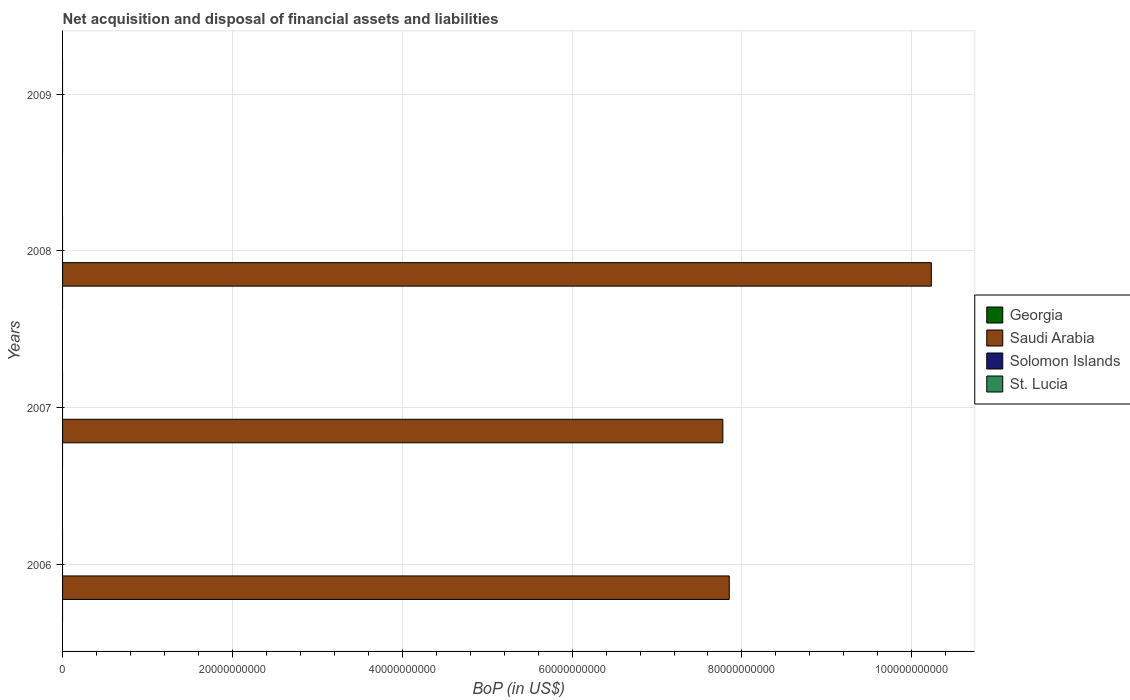How many different coloured bars are there?
Your answer should be compact. 1. Are the number of bars on each tick of the Y-axis equal?
Your answer should be compact. No. How many bars are there on the 4th tick from the bottom?
Give a very brief answer. 0. What is the label of the 4th group of bars from the top?
Provide a short and direct response. 2006. In how many cases, is the number of bars for a given year not equal to the number of legend labels?
Make the answer very short. 4. Across all years, what is the maximum Balance of Payments in Saudi Arabia?
Provide a short and direct response. 1.02e+11. What is the difference between the Balance of Payments in Saudi Arabia in 2006 and that in 2008?
Provide a short and direct response. -2.38e+1. What is the average Balance of Payments in Saudi Arabia per year?
Offer a terse response. 6.46e+1. What is the difference between the highest and the second highest Balance of Payments in Saudi Arabia?
Your answer should be compact. 2.38e+1. What is the difference between the highest and the lowest Balance of Payments in Saudi Arabia?
Keep it short and to the point. 1.02e+11. In how many years, is the Balance of Payments in Solomon Islands greater than the average Balance of Payments in Solomon Islands taken over all years?
Your response must be concise. 0. Is the sum of the Balance of Payments in Saudi Arabia in 2006 and 2007 greater than the maximum Balance of Payments in Solomon Islands across all years?
Make the answer very short. Yes. Is it the case that in every year, the sum of the Balance of Payments in Solomon Islands and Balance of Payments in Saudi Arabia is greater than the sum of Balance of Payments in Georgia and Balance of Payments in St. Lucia?
Offer a very short reply. No. Is it the case that in every year, the sum of the Balance of Payments in Saudi Arabia and Balance of Payments in Georgia is greater than the Balance of Payments in St. Lucia?
Ensure brevity in your answer.  No. Are all the bars in the graph horizontal?
Provide a succinct answer. Yes. How many years are there in the graph?
Provide a succinct answer. 4. What is the difference between two consecutive major ticks on the X-axis?
Give a very brief answer. 2.00e+1. Are the values on the major ticks of X-axis written in scientific E-notation?
Provide a short and direct response. No. Does the graph contain any zero values?
Your response must be concise. Yes. Does the graph contain grids?
Your response must be concise. Yes. How are the legend labels stacked?
Give a very brief answer. Vertical. What is the title of the graph?
Your response must be concise. Net acquisition and disposal of financial assets and liabilities. Does "Samoa" appear as one of the legend labels in the graph?
Make the answer very short. No. What is the label or title of the X-axis?
Provide a short and direct response. BoP (in US$). What is the label or title of the Y-axis?
Offer a very short reply. Years. What is the BoP (in US$) in Georgia in 2006?
Keep it short and to the point. 0. What is the BoP (in US$) of Saudi Arabia in 2006?
Your answer should be very brief. 7.85e+1. What is the BoP (in US$) in Solomon Islands in 2006?
Provide a short and direct response. 0. What is the BoP (in US$) in Saudi Arabia in 2007?
Provide a succinct answer. 7.78e+1. What is the BoP (in US$) in Solomon Islands in 2007?
Ensure brevity in your answer.  0. What is the BoP (in US$) in St. Lucia in 2007?
Give a very brief answer. 0. What is the BoP (in US$) of Saudi Arabia in 2008?
Offer a very short reply. 1.02e+11. What is the BoP (in US$) of Solomon Islands in 2008?
Provide a short and direct response. 0. What is the BoP (in US$) in Georgia in 2009?
Offer a terse response. 0. What is the BoP (in US$) of Saudi Arabia in 2009?
Offer a very short reply. 0. What is the BoP (in US$) in Solomon Islands in 2009?
Provide a short and direct response. 0. Across all years, what is the maximum BoP (in US$) of Saudi Arabia?
Provide a succinct answer. 1.02e+11. Across all years, what is the minimum BoP (in US$) of Saudi Arabia?
Offer a very short reply. 0. What is the total BoP (in US$) in Georgia in the graph?
Provide a succinct answer. 0. What is the total BoP (in US$) in Saudi Arabia in the graph?
Your answer should be compact. 2.59e+11. What is the total BoP (in US$) of Solomon Islands in the graph?
Your response must be concise. 0. What is the difference between the BoP (in US$) of Saudi Arabia in 2006 and that in 2007?
Ensure brevity in your answer.  7.55e+08. What is the difference between the BoP (in US$) in Saudi Arabia in 2006 and that in 2008?
Provide a short and direct response. -2.38e+1. What is the difference between the BoP (in US$) of Saudi Arabia in 2007 and that in 2008?
Your answer should be very brief. -2.45e+1. What is the average BoP (in US$) of Georgia per year?
Your answer should be very brief. 0. What is the average BoP (in US$) of Saudi Arabia per year?
Give a very brief answer. 6.46e+1. What is the average BoP (in US$) of St. Lucia per year?
Keep it short and to the point. 0. What is the ratio of the BoP (in US$) in Saudi Arabia in 2006 to that in 2007?
Ensure brevity in your answer.  1.01. What is the ratio of the BoP (in US$) of Saudi Arabia in 2006 to that in 2008?
Your response must be concise. 0.77. What is the ratio of the BoP (in US$) of Saudi Arabia in 2007 to that in 2008?
Ensure brevity in your answer.  0.76. What is the difference between the highest and the second highest BoP (in US$) of Saudi Arabia?
Make the answer very short. 2.38e+1. What is the difference between the highest and the lowest BoP (in US$) in Saudi Arabia?
Your response must be concise. 1.02e+11. 